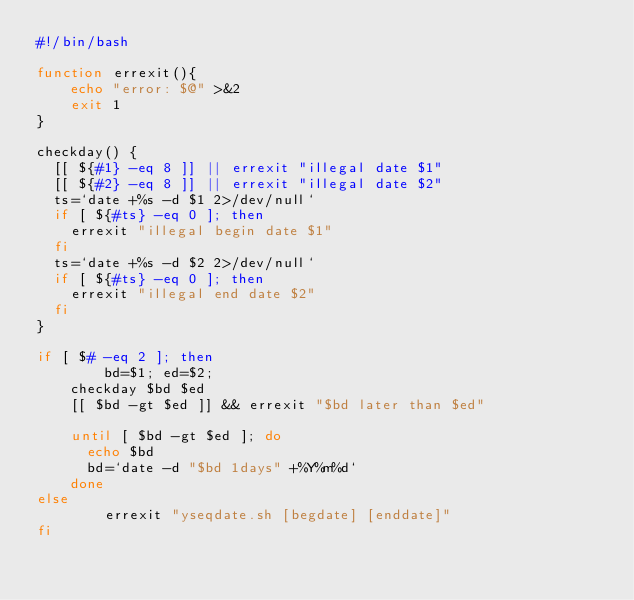<code> <loc_0><loc_0><loc_500><loc_500><_Bash_>#!/bin/bash

function errexit(){
    echo "error: $@" >&2
    exit 1
}

checkday() {
	[[ ${#1} -eq 8 ]] || errexit "illegal date $1"
	[[ ${#2} -eq 8 ]] || errexit "illegal date $2"
	ts=`date +%s -d $1 2>/dev/null`
	if [ ${#ts} -eq 0 ]; then
		errexit "illegal begin date $1"
	fi
	ts=`date +%s -d $2 2>/dev/null`
	if [ ${#ts} -eq 0 ]; then
		errexit "illegal end date $2"
	fi
}

if [ $# -eq 2 ]; then
        bd=$1; ed=$2;
		checkday $bd $ed
		[[ $bd -gt $ed ]] && errexit "$bd later than $ed"
		
		until [ $bd -gt $ed ]; do
			echo $bd
			bd=`date -d "$bd 1days" +%Y%m%d`
		done
else
        errexit "yseqdate.sh [begdate] [enddate]"
fi
</code> 